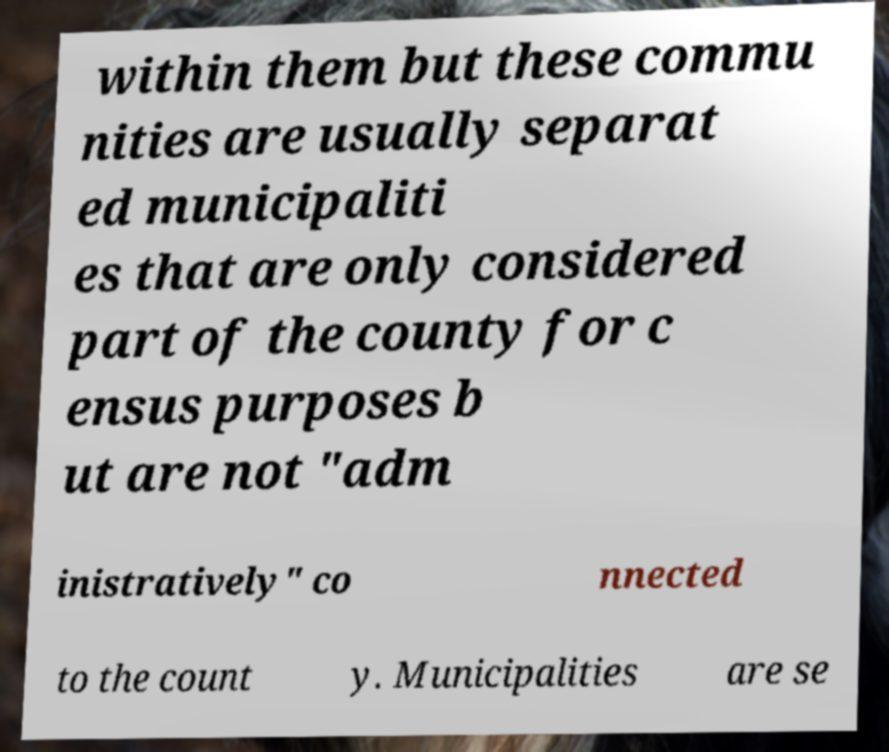For documentation purposes, I need the text within this image transcribed. Could you provide that? within them but these commu nities are usually separat ed municipaliti es that are only considered part of the county for c ensus purposes b ut are not "adm inistratively" co nnected to the count y. Municipalities are se 